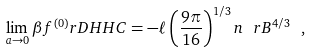<formula> <loc_0><loc_0><loc_500><loc_500>\lim _ { a \rightarrow 0 } \beta f ^ { ( 0 ) } _ { \ } r D H H C = - \ell \left ( \frac { 9 \pi } { 1 6 } \right ) ^ { 1 / 3 } n _ { \ } r B ^ { 4 / 3 } \ ,</formula> 